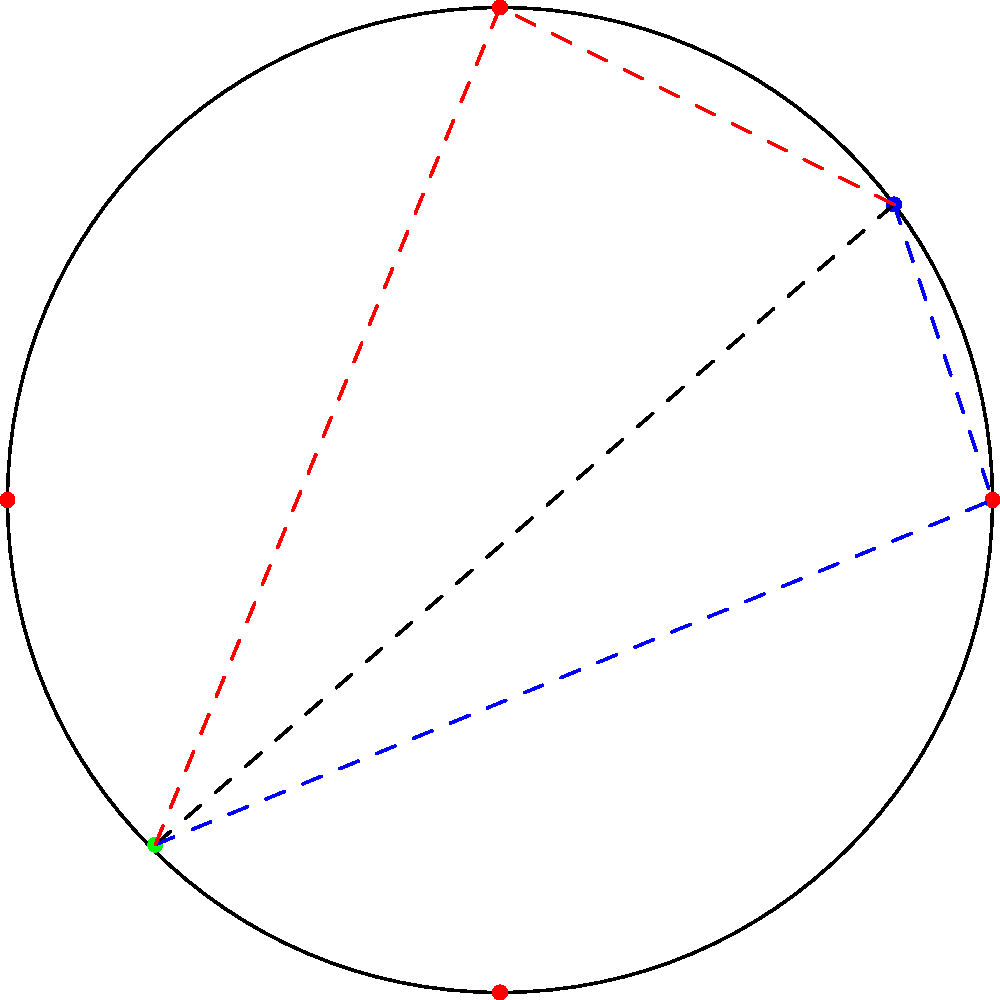In a circular stadium, you enter at the blue dot and need to exit at the green dot. There are four possible pit stops at the red dots. What's the shortest path to the exit if you must visit exactly one pit stop? To find the shortest path, we need to consider the distance from the entrance (blue dot) to each pit stop (red dot) and then to the exit (green dot). Here's the step-by-step process:

1. Identify the four possible paths:
   a) Entrance → Right pit stop → Exit
   b) Entrance → Top pit stop → Exit
   c) Entrance → Left pit stop → Exit
   d) Entrance → Bottom pit stop → Exit

2. Visually, we can eliminate the left and bottom pit stops as they are clearly farther from both the entrance and exit.

3. Between the right and top pit stops, the right one appears to be slightly closer to both the entrance and exit.

4. The blue dashed line in the diagram represents the path through the right pit stop, which is visually the shortest.

5. The red dashed line shows the path through the top pit stop for comparison.

6. While an exact measurement would require more precise coordinates and calculations, we can conclude based on the visual representation that the path through the right pit stop is the shortest.
Answer: Entrance → Right pit stop → Exit 